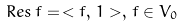<formula> <loc_0><loc_0><loc_500><loc_500>R e s \, f = \, < f , \, 1 > , \, f \in V _ { 0 }</formula> 